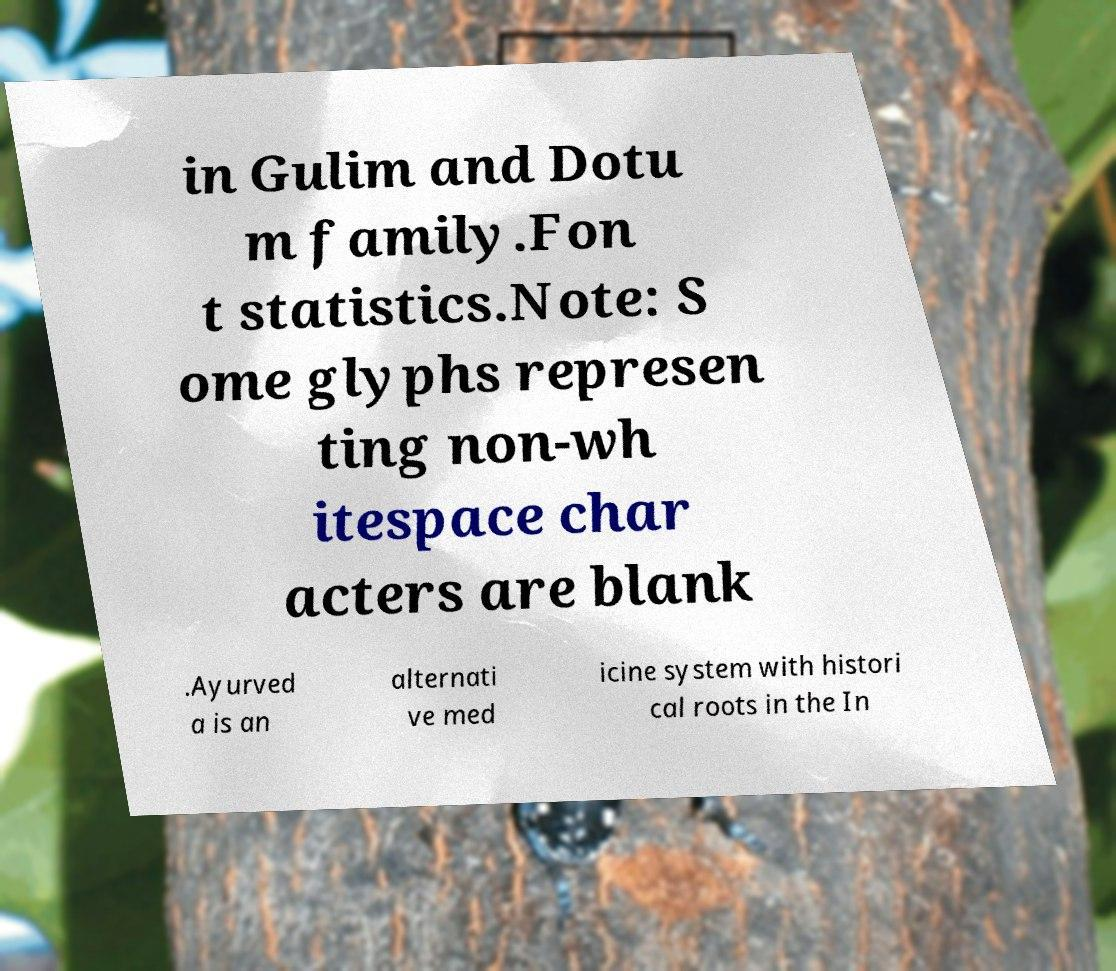For documentation purposes, I need the text within this image transcribed. Could you provide that? in Gulim and Dotu m family.Fon t statistics.Note: S ome glyphs represen ting non-wh itespace char acters are blank .Ayurved a is an alternati ve med icine system with histori cal roots in the In 